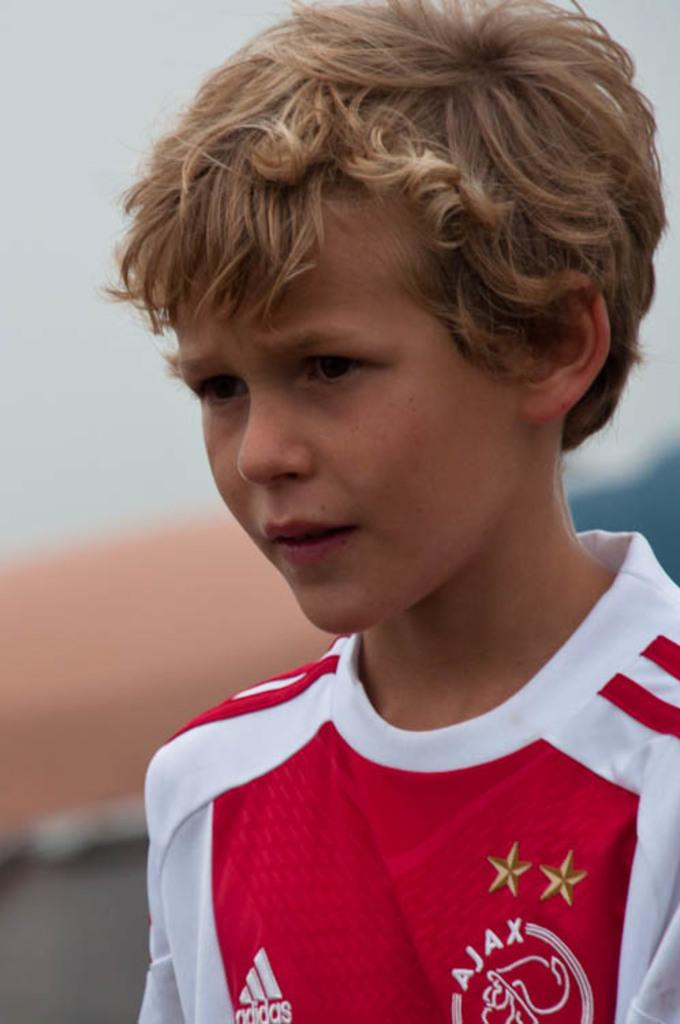<image>
Describe the image concisely. a boy that had the word Adidas on his jersey 